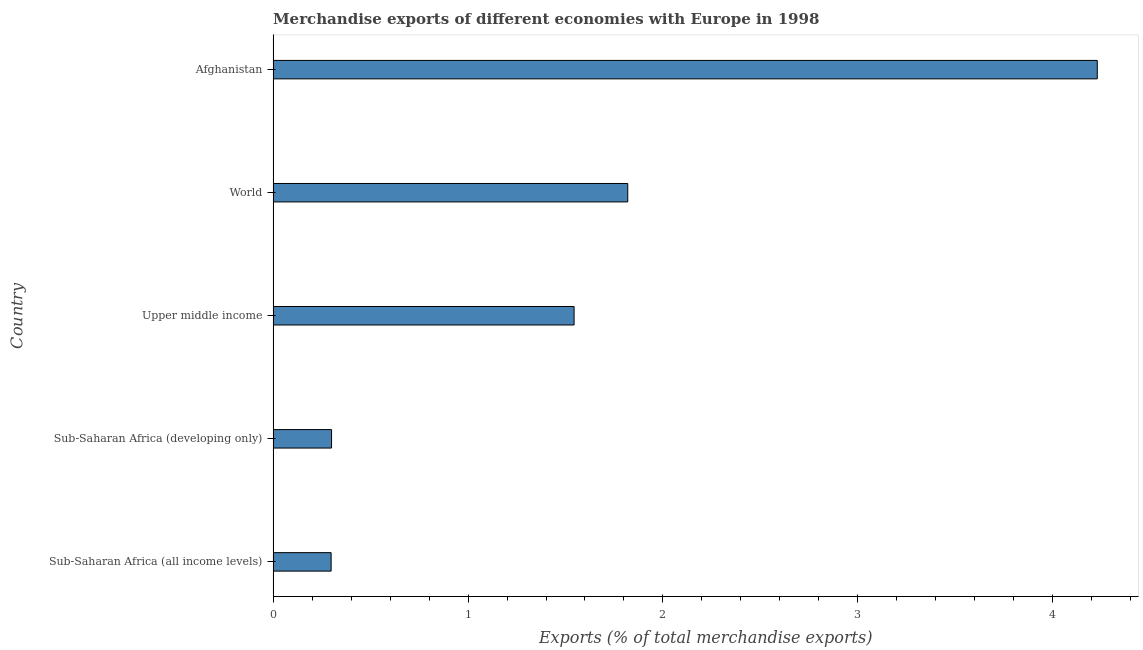Does the graph contain grids?
Provide a short and direct response. No. What is the title of the graph?
Offer a very short reply. Merchandise exports of different economies with Europe in 1998. What is the label or title of the X-axis?
Your answer should be very brief. Exports (% of total merchandise exports). What is the label or title of the Y-axis?
Give a very brief answer. Country. What is the merchandise exports in World?
Your answer should be very brief. 1.82. Across all countries, what is the maximum merchandise exports?
Offer a terse response. 4.23. Across all countries, what is the minimum merchandise exports?
Keep it short and to the point. 0.3. In which country was the merchandise exports maximum?
Make the answer very short. Afghanistan. In which country was the merchandise exports minimum?
Provide a short and direct response. Sub-Saharan Africa (all income levels). What is the sum of the merchandise exports?
Give a very brief answer. 8.19. What is the difference between the merchandise exports in Sub-Saharan Africa (all income levels) and World?
Provide a succinct answer. -1.52. What is the average merchandise exports per country?
Keep it short and to the point. 1.64. What is the median merchandise exports?
Offer a terse response. 1.54. What is the ratio of the merchandise exports in Afghanistan to that in World?
Provide a succinct answer. 2.32. Is the merchandise exports in Sub-Saharan Africa (all income levels) less than that in World?
Your answer should be compact. Yes. What is the difference between the highest and the second highest merchandise exports?
Your answer should be compact. 2.41. What is the difference between the highest and the lowest merchandise exports?
Offer a very short reply. 3.93. In how many countries, is the merchandise exports greater than the average merchandise exports taken over all countries?
Your response must be concise. 2. How many bars are there?
Offer a very short reply. 5. Are the values on the major ticks of X-axis written in scientific E-notation?
Ensure brevity in your answer.  No. What is the Exports (% of total merchandise exports) in Sub-Saharan Africa (all income levels)?
Provide a succinct answer. 0.3. What is the Exports (% of total merchandise exports) in Sub-Saharan Africa (developing only)?
Make the answer very short. 0.3. What is the Exports (% of total merchandise exports) in Upper middle income?
Offer a very short reply. 1.54. What is the Exports (% of total merchandise exports) of World?
Provide a succinct answer. 1.82. What is the Exports (% of total merchandise exports) in Afghanistan?
Make the answer very short. 4.23. What is the difference between the Exports (% of total merchandise exports) in Sub-Saharan Africa (all income levels) and Sub-Saharan Africa (developing only)?
Provide a succinct answer. -0. What is the difference between the Exports (% of total merchandise exports) in Sub-Saharan Africa (all income levels) and Upper middle income?
Make the answer very short. -1.25. What is the difference between the Exports (% of total merchandise exports) in Sub-Saharan Africa (all income levels) and World?
Provide a short and direct response. -1.52. What is the difference between the Exports (% of total merchandise exports) in Sub-Saharan Africa (all income levels) and Afghanistan?
Make the answer very short. -3.93. What is the difference between the Exports (% of total merchandise exports) in Sub-Saharan Africa (developing only) and Upper middle income?
Your answer should be very brief. -1.24. What is the difference between the Exports (% of total merchandise exports) in Sub-Saharan Africa (developing only) and World?
Offer a very short reply. -1.52. What is the difference between the Exports (% of total merchandise exports) in Sub-Saharan Africa (developing only) and Afghanistan?
Offer a very short reply. -3.93. What is the difference between the Exports (% of total merchandise exports) in Upper middle income and World?
Ensure brevity in your answer.  -0.28. What is the difference between the Exports (% of total merchandise exports) in Upper middle income and Afghanistan?
Your answer should be compact. -2.68. What is the difference between the Exports (% of total merchandise exports) in World and Afghanistan?
Offer a terse response. -2.41. What is the ratio of the Exports (% of total merchandise exports) in Sub-Saharan Africa (all income levels) to that in Sub-Saharan Africa (developing only)?
Make the answer very short. 0.99. What is the ratio of the Exports (% of total merchandise exports) in Sub-Saharan Africa (all income levels) to that in Upper middle income?
Your response must be concise. 0.19. What is the ratio of the Exports (% of total merchandise exports) in Sub-Saharan Africa (all income levels) to that in World?
Your answer should be very brief. 0.16. What is the ratio of the Exports (% of total merchandise exports) in Sub-Saharan Africa (all income levels) to that in Afghanistan?
Ensure brevity in your answer.  0.07. What is the ratio of the Exports (% of total merchandise exports) in Sub-Saharan Africa (developing only) to that in Upper middle income?
Your answer should be very brief. 0.19. What is the ratio of the Exports (% of total merchandise exports) in Sub-Saharan Africa (developing only) to that in World?
Keep it short and to the point. 0.17. What is the ratio of the Exports (% of total merchandise exports) in Sub-Saharan Africa (developing only) to that in Afghanistan?
Provide a short and direct response. 0.07. What is the ratio of the Exports (% of total merchandise exports) in Upper middle income to that in World?
Give a very brief answer. 0.85. What is the ratio of the Exports (% of total merchandise exports) in Upper middle income to that in Afghanistan?
Offer a terse response. 0.36. What is the ratio of the Exports (% of total merchandise exports) in World to that in Afghanistan?
Your answer should be very brief. 0.43. 